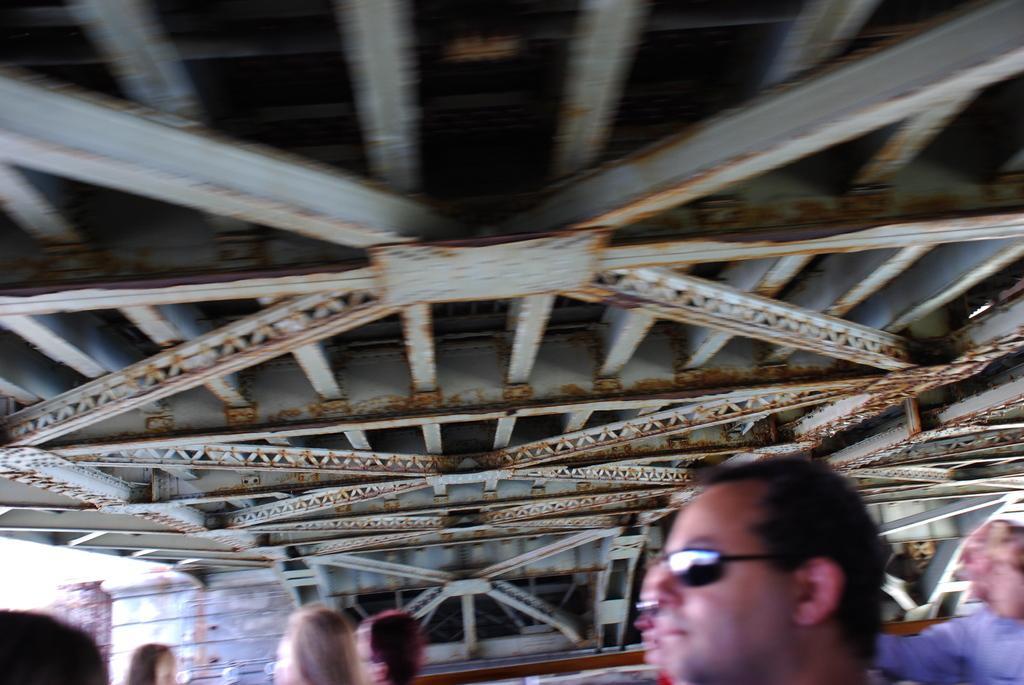Describe this image in one or two sentences. In this image I can see a group of people, metal rods, wall and door. This image is taken may be during a day. 